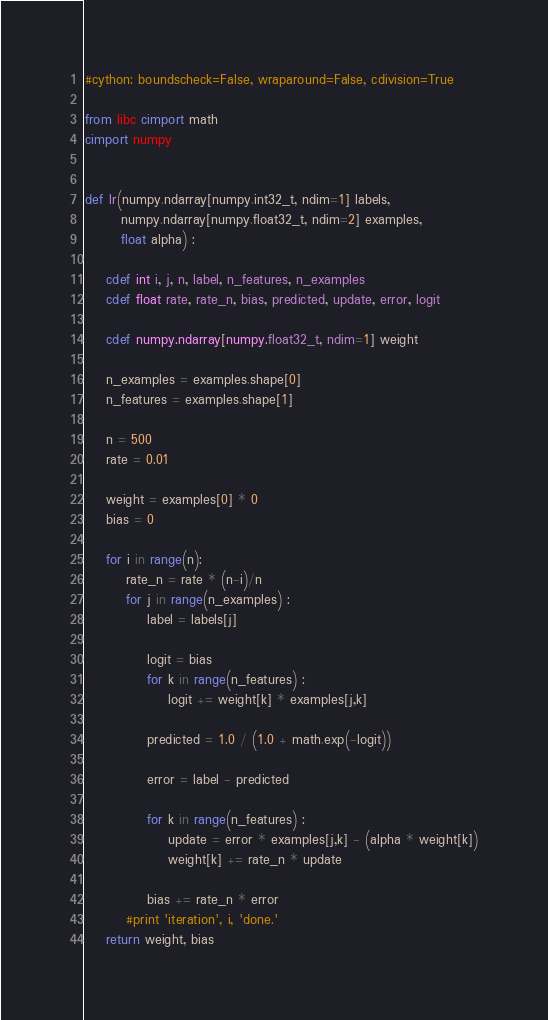<code> <loc_0><loc_0><loc_500><loc_500><_Cython_>#cython: boundscheck=False, wraparound=False, cdivision=True

from libc cimport math
cimport numpy


def lr(numpy.ndarray[numpy.int32_t, ndim=1] labels,
       numpy.ndarray[numpy.float32_t, ndim=2] examples,
       float alpha) :

    cdef int i, j, n, label, n_features, n_examples
    cdef float rate, rate_n, bias, predicted, update, error, logit

    cdef numpy.ndarray[numpy.float32_t, ndim=1] weight

    n_examples = examples.shape[0]
    n_features = examples.shape[1]

    n = 500
    rate = 0.01

    weight = examples[0] * 0
    bias = 0

    for i in range(n):
        rate_n = rate * (n-i)/n
        for j in range(n_examples) :
            label = labels[j]

            logit = bias
            for k in range(n_features) :
                logit += weight[k] * examples[j,k]

            predicted = 1.0 / (1.0 + math.exp(-logit))
                
            error = label - predicted
            
            for k in range(n_features) :
                update = error * examples[j,k] - (alpha * weight[k])
                weight[k] += rate_n * update
            
            bias += rate_n * error
        #print 'iteration', i, 'done.'
    return weight, bias 

</code> 